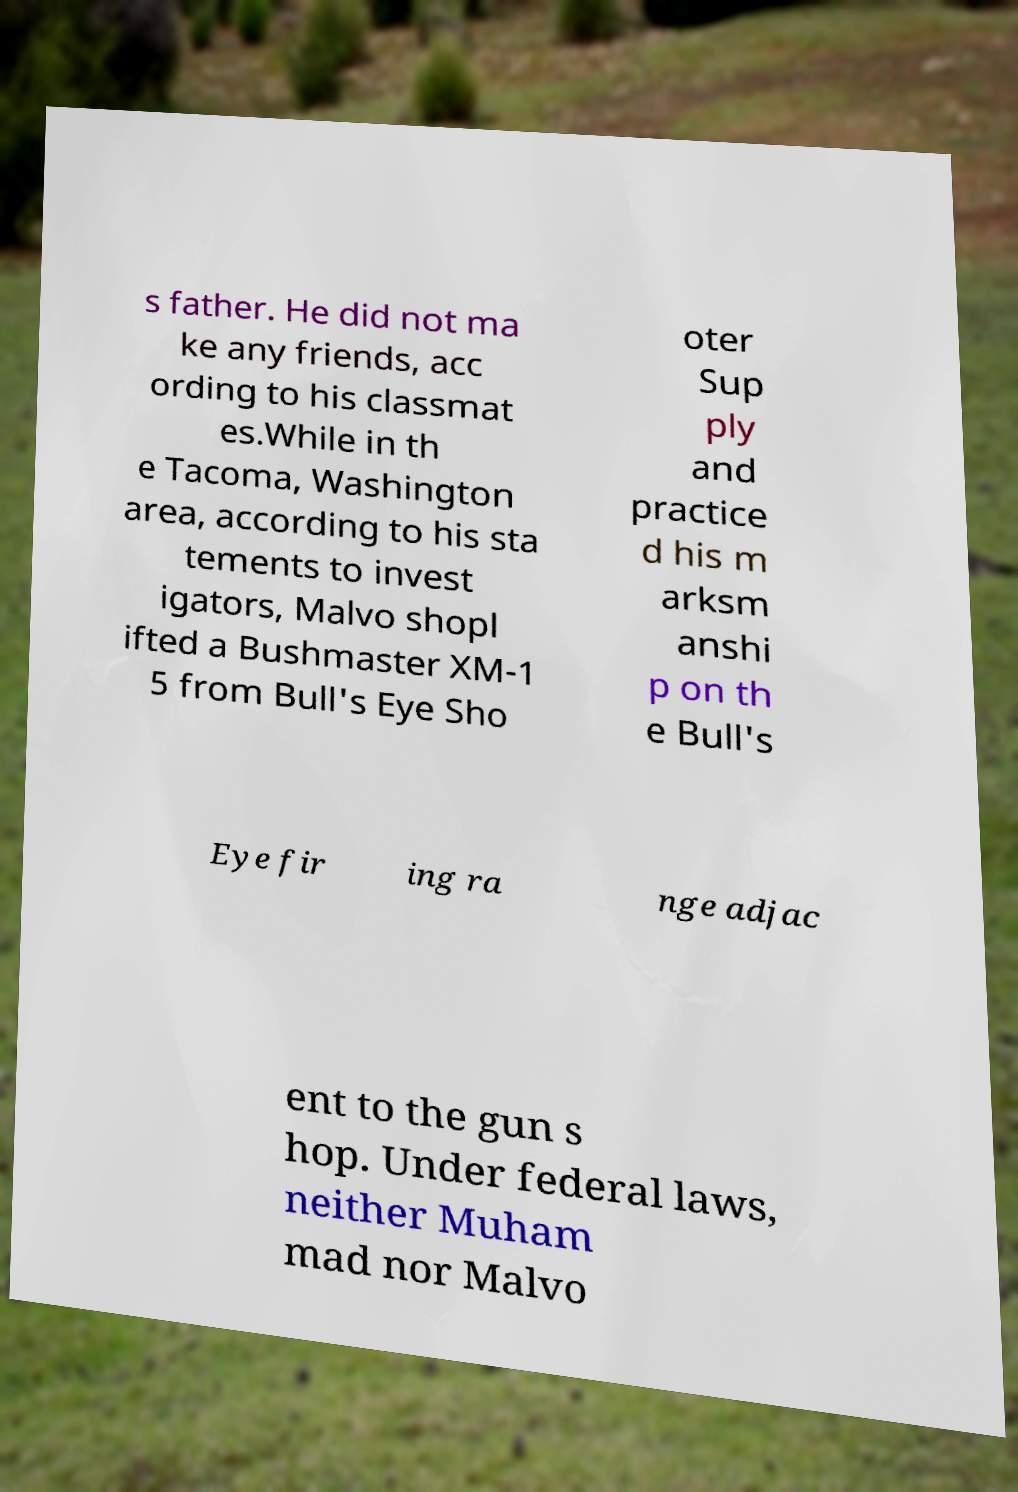Could you assist in decoding the text presented in this image and type it out clearly? s father. He did not ma ke any friends, acc ording to his classmat es.While in th e Tacoma, Washington area, according to his sta tements to invest igators, Malvo shopl ifted a Bushmaster XM-1 5 from Bull's Eye Sho oter Sup ply and practice d his m arksm anshi p on th e Bull's Eye fir ing ra nge adjac ent to the gun s hop. Under federal laws, neither Muham mad nor Malvo 